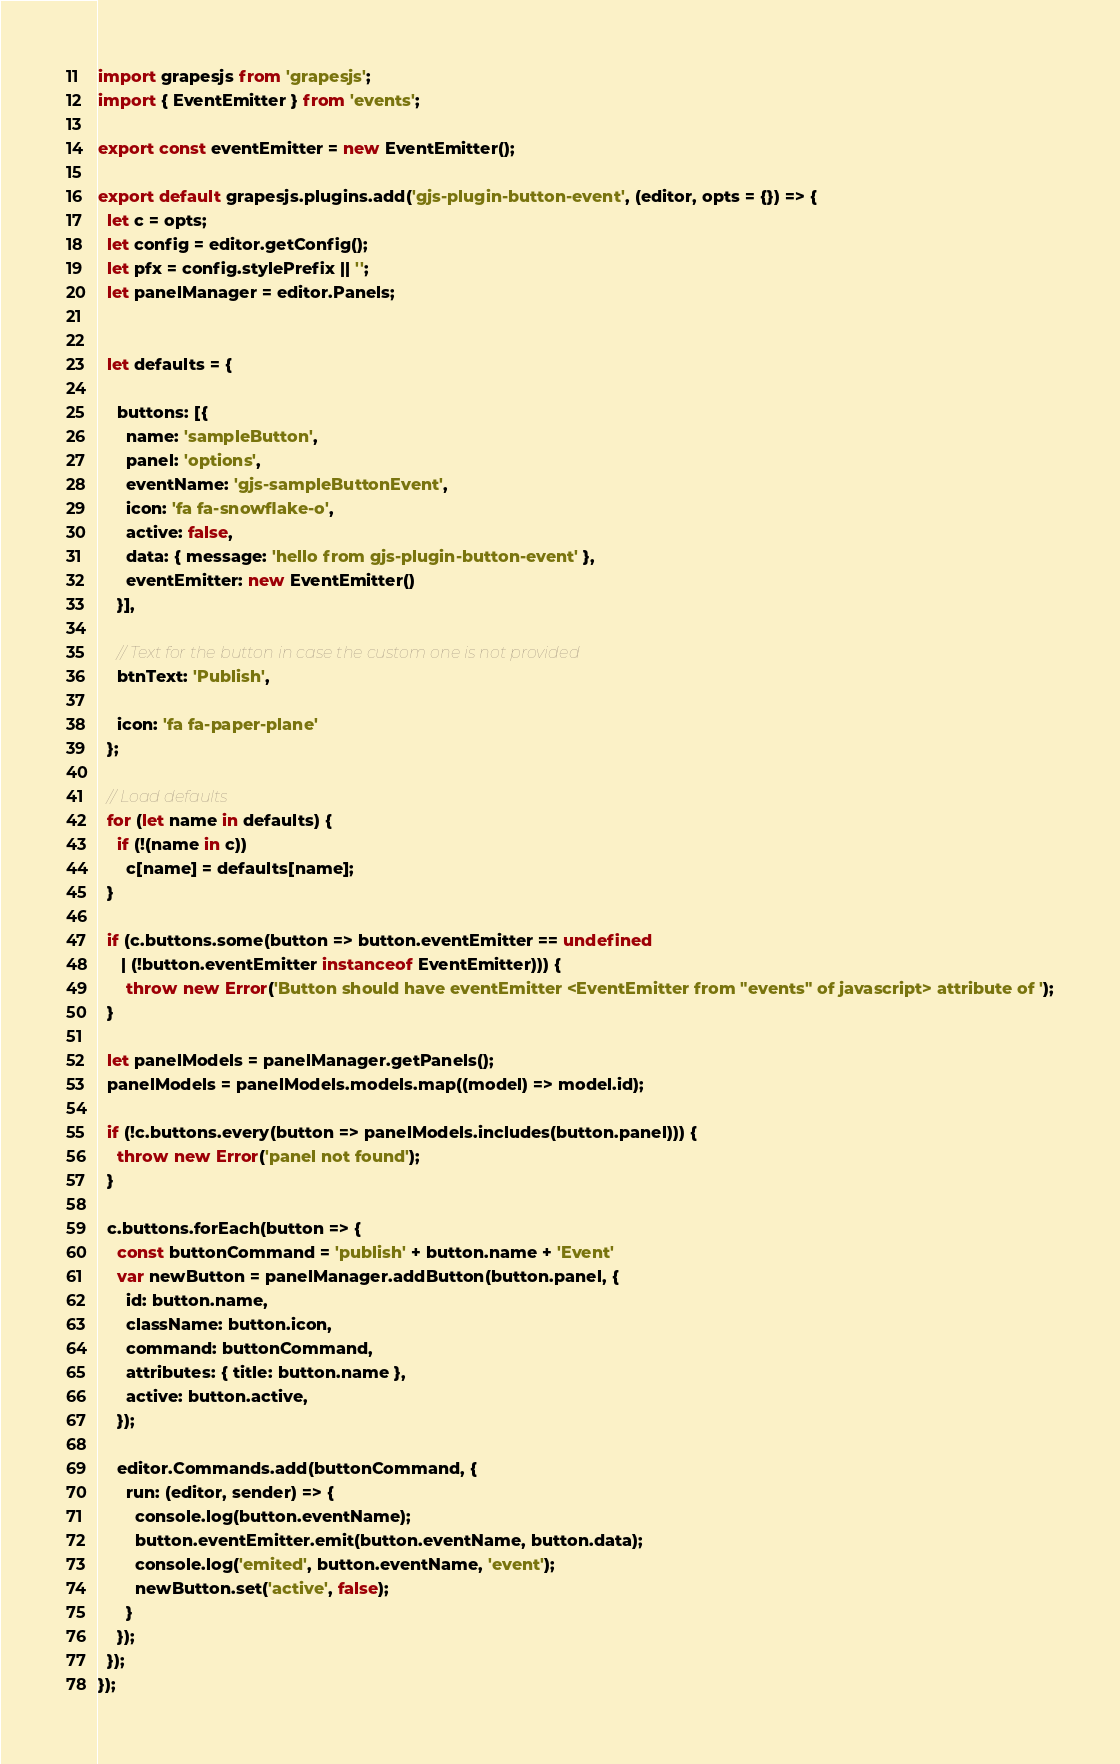Convert code to text. <code><loc_0><loc_0><loc_500><loc_500><_JavaScript_>import grapesjs from 'grapesjs';
import { EventEmitter } from 'events';

export const eventEmitter = new EventEmitter();

export default grapesjs.plugins.add('gjs-plugin-button-event', (editor, opts = {}) => {
  let c = opts;
  let config = editor.getConfig();
  let pfx = config.stylePrefix || '';
  let panelManager = editor.Panels;
  

  let defaults = {

    buttons: [{
      name: 'sampleButton',
      panel: 'options',
      eventName: 'gjs-sampleButtonEvent',
      icon: 'fa fa-snowflake-o',
      active: false,
      data: { message: 'hello from gjs-plugin-button-event' },
      eventEmitter: new EventEmitter()
    }],

    // Text for the button in case the custom one is not provided
    btnText: 'Publish',

    icon: 'fa fa-paper-plane'
  };

  // Load defaults
  for (let name in defaults) {
    if (!(name in c))
      c[name] = defaults[name];
  }

  if (c.buttons.some(button => button.eventEmitter == undefined
     | (!button.eventEmitter instanceof EventEmitter))) {
      throw new Error('Button should have eventEmitter <EventEmitter from "events" of javascript> attribute of ');
  }

  let panelModels = panelManager.getPanels();
  panelModels = panelModels.models.map((model) => model.id);

  if (!c.buttons.every(button => panelModels.includes(button.panel))) {
    throw new Error('panel not found');
  }

  c.buttons.forEach(button => {
    const buttonCommand = 'publish' + button.name + 'Event'
    var newButton = panelManager.addButton(button.panel, {
      id: button.name,
      className: button.icon,
      command: buttonCommand,
      attributes: { title: button.name },
      active: button.active,
    });

    editor.Commands.add(buttonCommand, {
      run: (editor, sender) => {
        console.log(button.eventName);
        button.eventEmitter.emit(button.eventName, button.data);
        console.log('emited', button.eventName, 'event');
        newButton.set('active', false);
      }
    });
  });
});</code> 